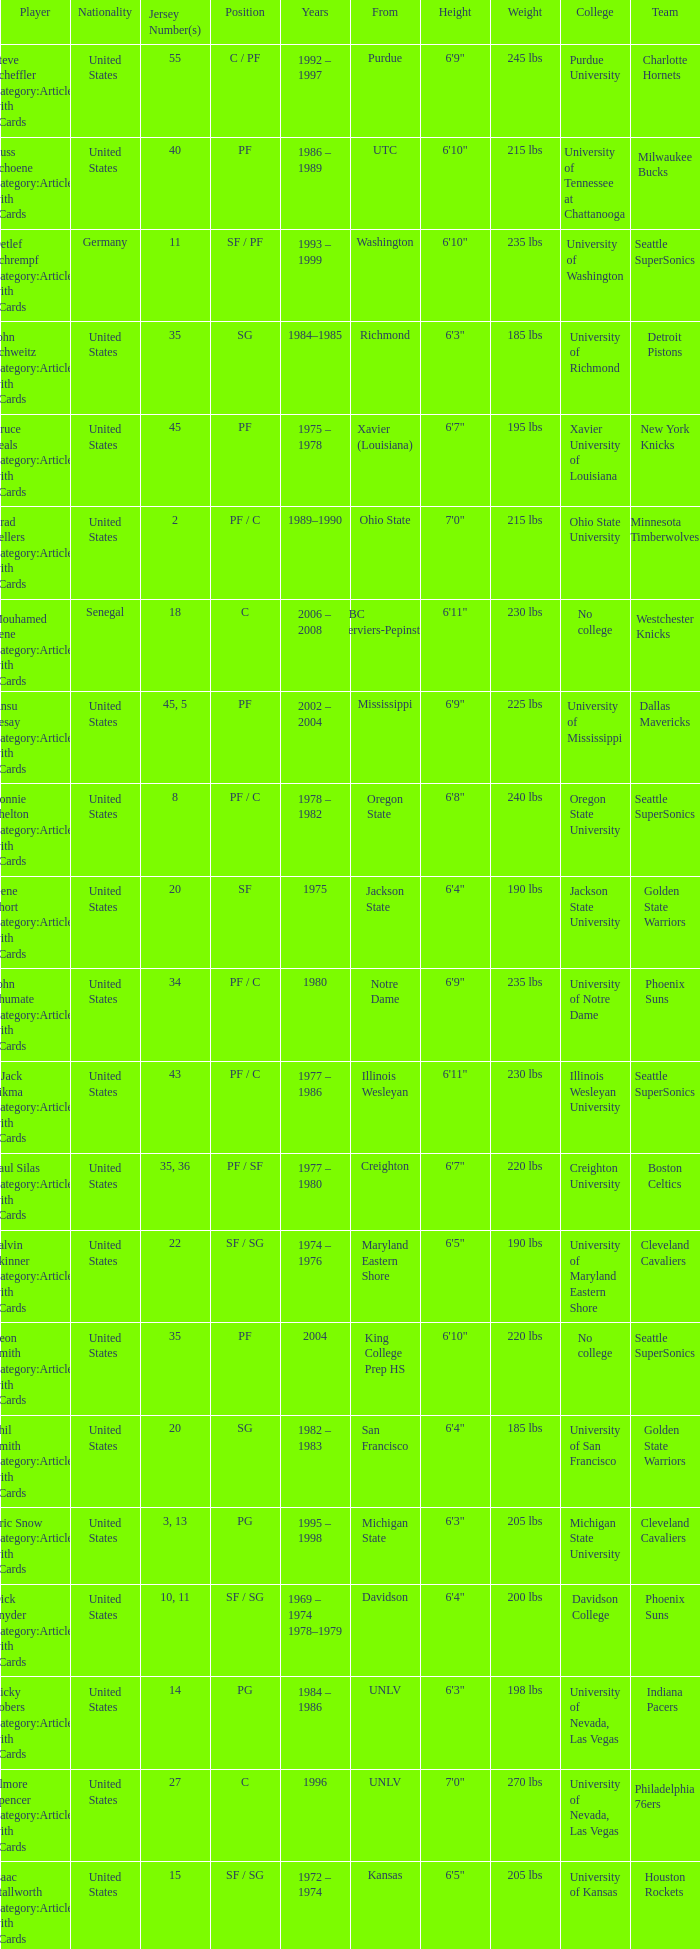What nationality is the player from Oregon State? United States. 